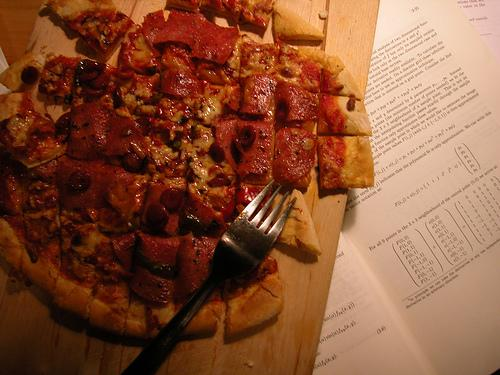Mention a peculiar detail you noticed about the image. There's an open book under the wooden platter where the pizza is placed. Describe a hidden detail or something someone might overlook in the image. There's a piece of crust hanging over the edge of the pizza with no toppings on it. Imagine you are the cook of this pizza: describe the final result of your creation as seen in the image. My round pepperoni pizza, sliced into small, square bites, rests alluringly on a wooden tray atop an open book, with a silver fork ready for the first taste. Explain the process of eating this pizza, given what's shown in the image. Pick up the silver fork, select a small, square bite of the pepperoni pizza, and indulge in the flavors of melted cheese, pepperoni, and well-cooked crust. Write a headline for a news article based on the image. "Pepperoni Pizza Delight: A Mouthwatering Feast Served on a Wooden Tray atop an Open Book!" Describe the placement of the fork in relation to the pizza and other elements in the image. The silver fork is placed on top of the pizza, which is cut into small squares and lies on a wooden tray over an open book. Provide three aspects or items that stand out in the image. A round pizza cut into small bites, a silver fork on the pizza, and an open book underneath the wooden tray. Tell a story in one sentence about what led to the moment captured in the image. After placing their freshly cooked pizza on the wooden tray, someone accidentally set it on top of an open book, then grabbed a silver fork to dig in. List the types of foods you can see in the image. A round pizza with pepperoni, melted cheese, and black olives, cut into small square bites, with a silver fork on top of it. Write a haiku to describe the image. Open book awaits. 